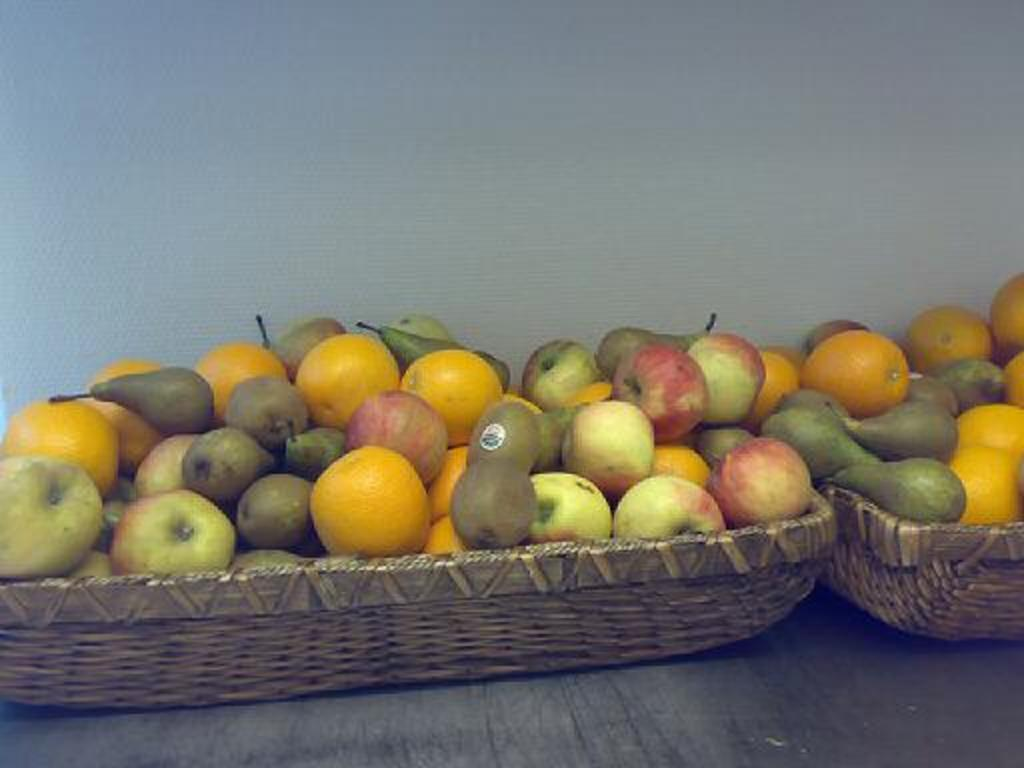What is in the basket that is visible in the image? There are fruits in a basket in the image. Where is the basket located in the image? The basket is placed on a table in the image. What can be seen in the background of the image? There is a wall visible in the background of the image. What type of record is being played in the image? There is no record or music player present in the image; it only features a basket of fruits on a table with a wall in the background. 